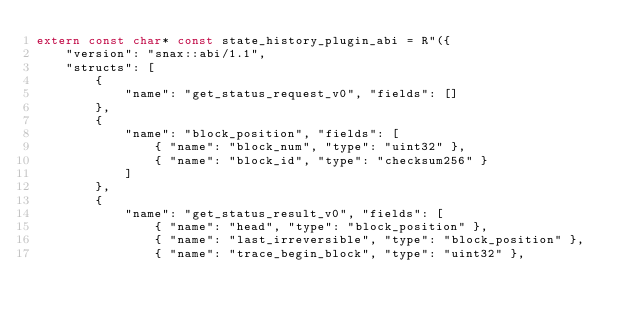<code> <loc_0><loc_0><loc_500><loc_500><_C++_>extern const char* const state_history_plugin_abi = R"({
    "version": "snax::abi/1.1",
    "structs": [
        {
            "name": "get_status_request_v0", "fields": []
        },
        {
            "name": "block_position", "fields": [
                { "name": "block_num", "type": "uint32" },
                { "name": "block_id", "type": "checksum256" }
            ]
        },
        {
            "name": "get_status_result_v0", "fields": [
                { "name": "head", "type": "block_position" },
                { "name": "last_irreversible", "type": "block_position" },
                { "name": "trace_begin_block", "type": "uint32" },</code> 